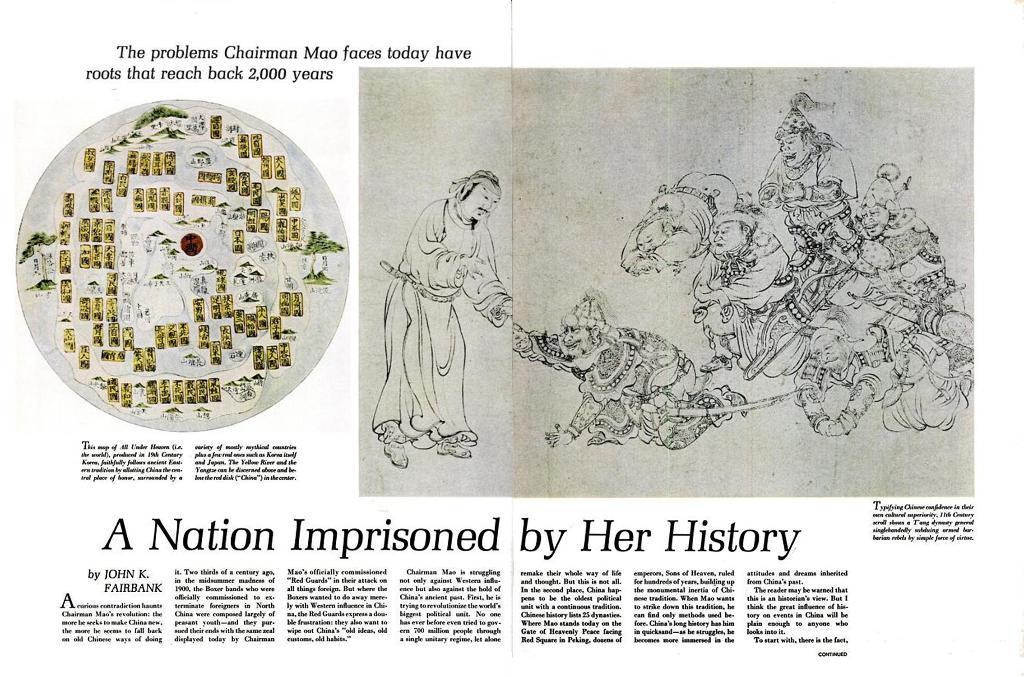What is the primary object in the image? There is a paper in the image. What is featured on the paper? The paper contains text and pictures of people. What type of quince is depicted in the image? There is no quince present in the image; it features a paper with text and pictures of people. How is the toothpaste being used in the image? There is no toothpaste present in the image. 